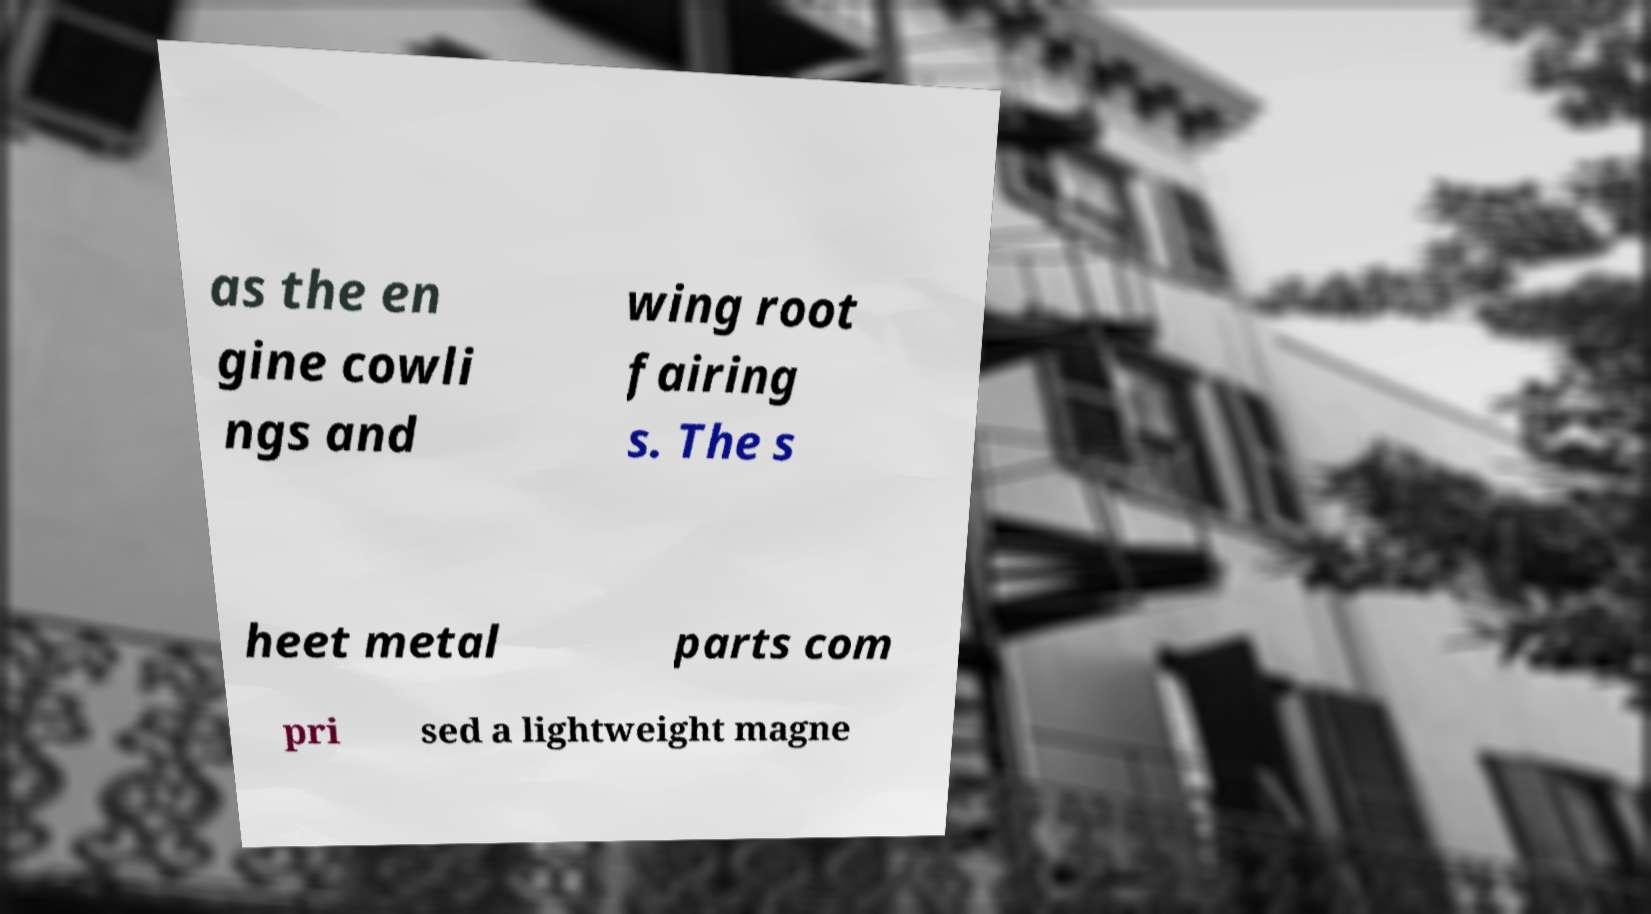Can you accurately transcribe the text from the provided image for me? as the en gine cowli ngs and wing root fairing s. The s heet metal parts com pri sed a lightweight magne 